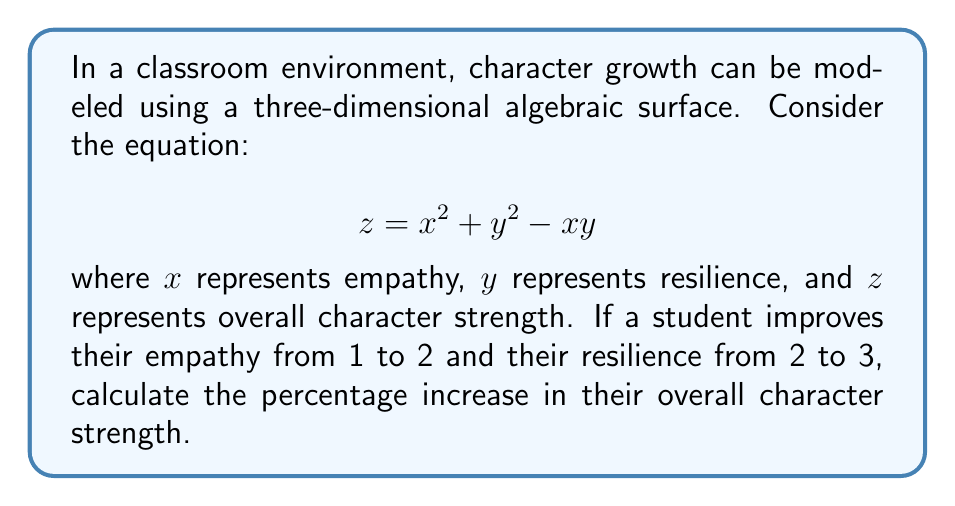What is the answer to this math problem? 1. Let's calculate the initial character strength:
   For $x_1 = 1$ and $y_1 = 2$:
   $$z_1 = 1^2 + 2^2 - 1(2) = 1 + 4 - 2 = 3$$

2. Now, calculate the final character strength:
   For $x_2 = 2$ and $y_2 = 3$:
   $$z_2 = 2^2 + 3^2 - 2(3) = 4 + 9 - 6 = 7$$

3. Calculate the difference in character strength:
   $$\text{Difference} = z_2 - z_1 = 7 - 3 = 4$$

4. Calculate the percentage increase:
   $$\text{Percentage Increase} = \frac{\text{Difference}}{\text{Initial Value}} \times 100\%$$
   $$= \frac{4}{3} \times 100\% \approx 133.33\%$$

5. Round to the nearest whole percent:
   133%
Answer: 133% 